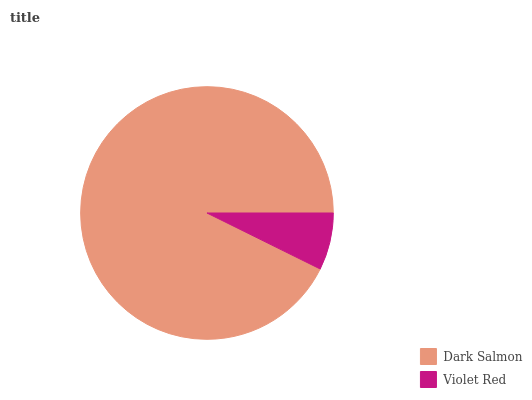Is Violet Red the minimum?
Answer yes or no. Yes. Is Dark Salmon the maximum?
Answer yes or no. Yes. Is Violet Red the maximum?
Answer yes or no. No. Is Dark Salmon greater than Violet Red?
Answer yes or no. Yes. Is Violet Red less than Dark Salmon?
Answer yes or no. Yes. Is Violet Red greater than Dark Salmon?
Answer yes or no. No. Is Dark Salmon less than Violet Red?
Answer yes or no. No. Is Dark Salmon the high median?
Answer yes or no. Yes. Is Violet Red the low median?
Answer yes or no. Yes. Is Violet Red the high median?
Answer yes or no. No. Is Dark Salmon the low median?
Answer yes or no. No. 